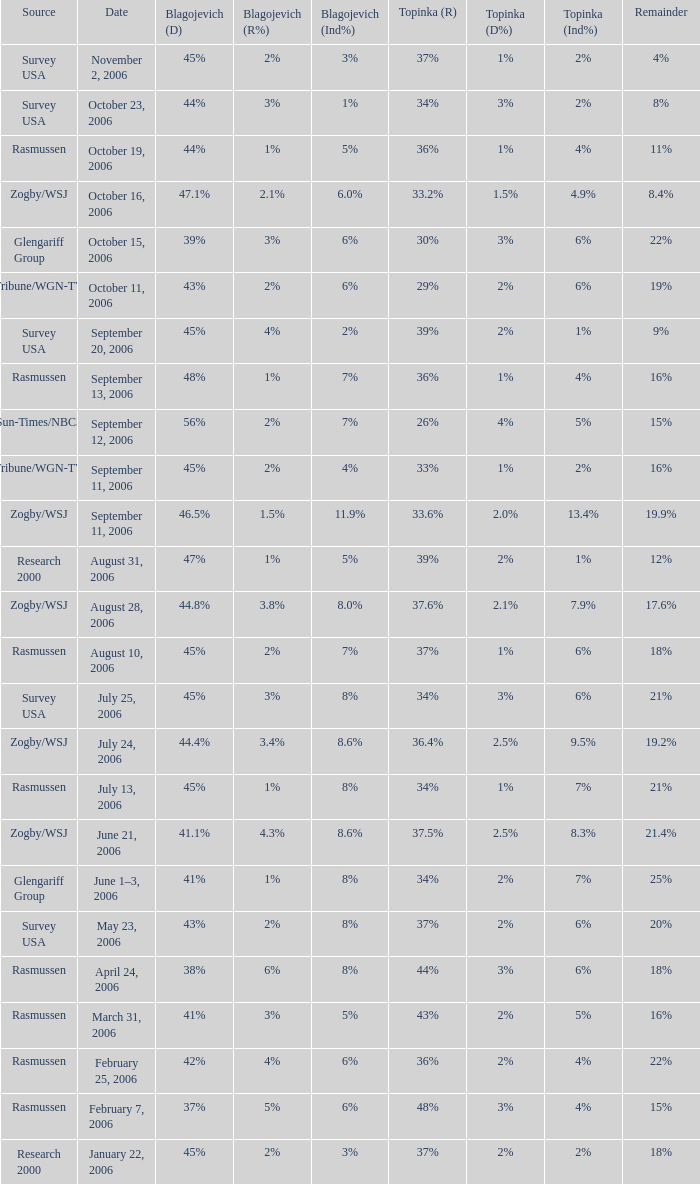Which Blagojevich (D) has a Source of zogby/wsj, and a Topinka (R) of 33.2%? 47.1%. 